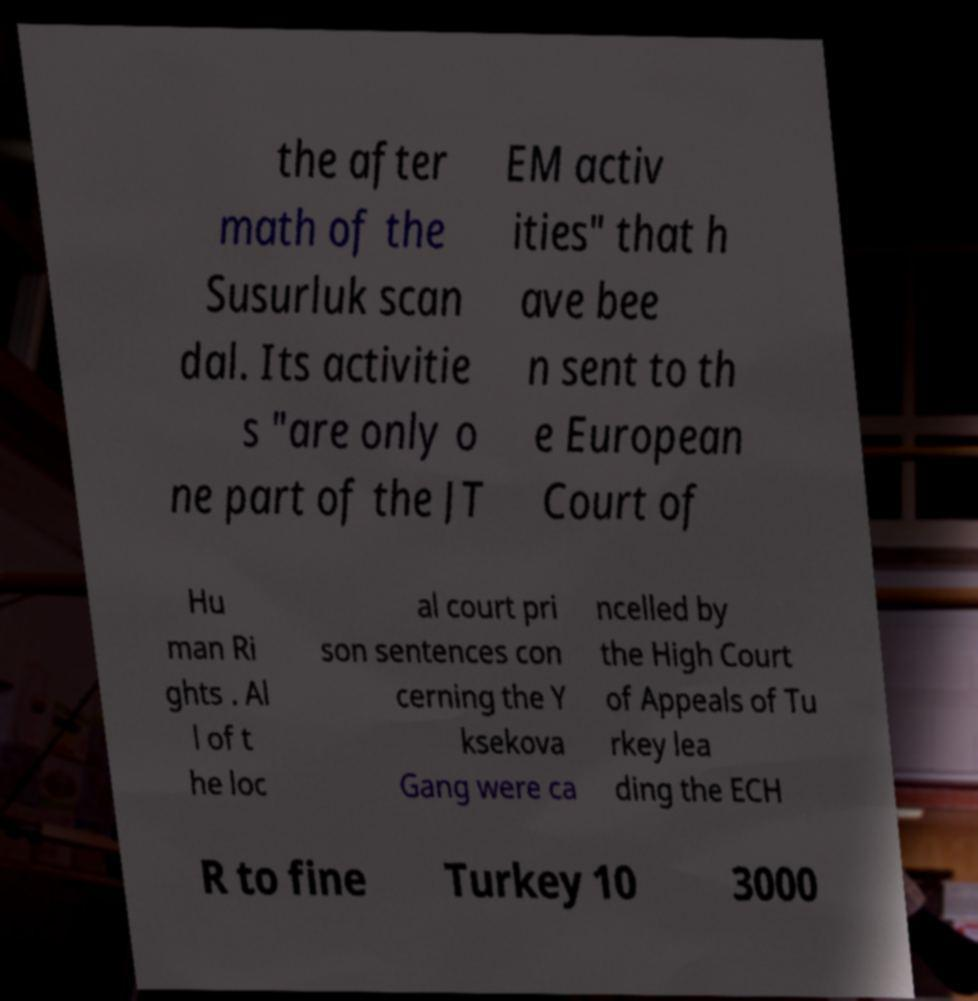Please read and relay the text visible in this image. What does it say? the after math of the Susurluk scan dal. Its activitie s "are only o ne part of the JT EM activ ities" that h ave bee n sent to th e European Court of Hu man Ri ghts . Al l of t he loc al court pri son sentences con cerning the Y ksekova Gang were ca ncelled by the High Court of Appeals of Tu rkey lea ding the ECH R to fine Turkey 10 3000 